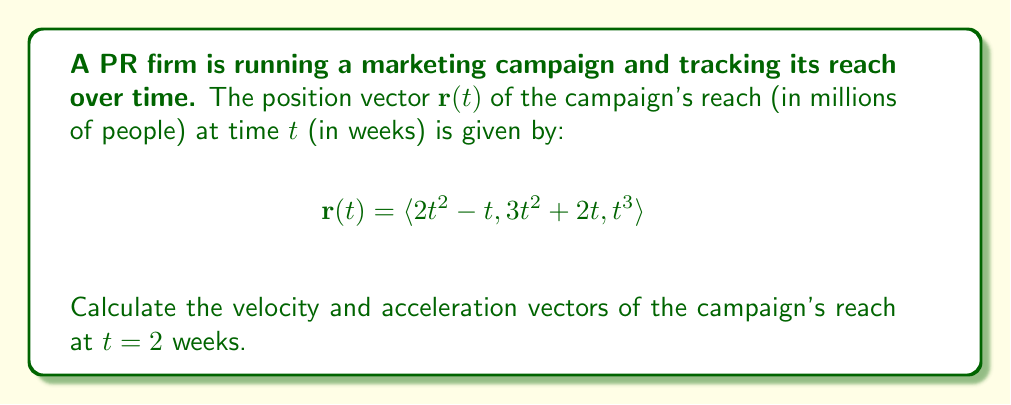Can you solve this math problem? To solve this problem, we need to find the velocity and acceleration vectors by differentiating the position vector.

1. Velocity vector:
The velocity vector is the first derivative of the position vector with respect to time.

$$\mathbf{v}(t) = \frac{d\mathbf{r}}{dt} = \langle \frac{d}{dt}(2t^2 - t), \frac{d}{dt}(3t^2 + 2t), \frac{d}{dt}(t^3) \rangle$$

$$\mathbf{v}(t) = \langle 4t - 1, 6t + 2, 3t^2 \rangle$$

2. Acceleration vector:
The acceleration vector is the second derivative of the position vector, or the first derivative of the velocity vector.

$$\mathbf{a}(t) = \frac{d\mathbf{v}}{dt} = \langle \frac{d}{dt}(4t - 1), \frac{d}{dt}(6t + 2), \frac{d}{dt}(3t^2) \rangle$$

$$\mathbf{a}(t) = \langle 4, 6, 6t \rangle$$

3. Evaluate at $t = 2$:

Velocity at $t = 2$:
$$\mathbf{v}(2) = \langle 4(2) - 1, 6(2) + 2, 3(2)^2 \rangle = \langle 7, 14, 12 \rangle$$

Acceleration at $t = 2$:
$$\mathbf{a}(2) = \langle 4, 6, 6(2) \rangle = \langle 4, 6, 12 \rangle$$
Answer: Velocity vector at $t = 2$ weeks: $\mathbf{v}(2) = \langle 7, 14, 12 \rangle$ million people/week
Acceleration vector at $t = 2$ weeks: $\mathbf{a}(2) = \langle 4, 6, 12 \rangle$ million people/week² 